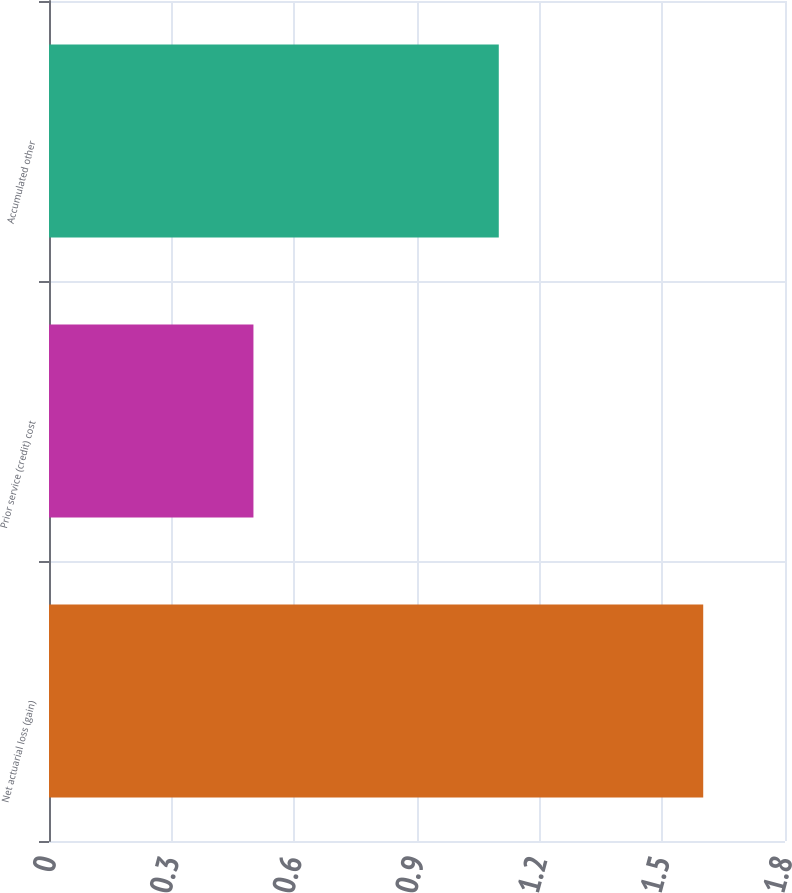<chart> <loc_0><loc_0><loc_500><loc_500><bar_chart><fcel>Net actuarial loss (gain)<fcel>Prior service (credit) cost<fcel>Accumulated other<nl><fcel>1.6<fcel>0.5<fcel>1.1<nl></chart> 